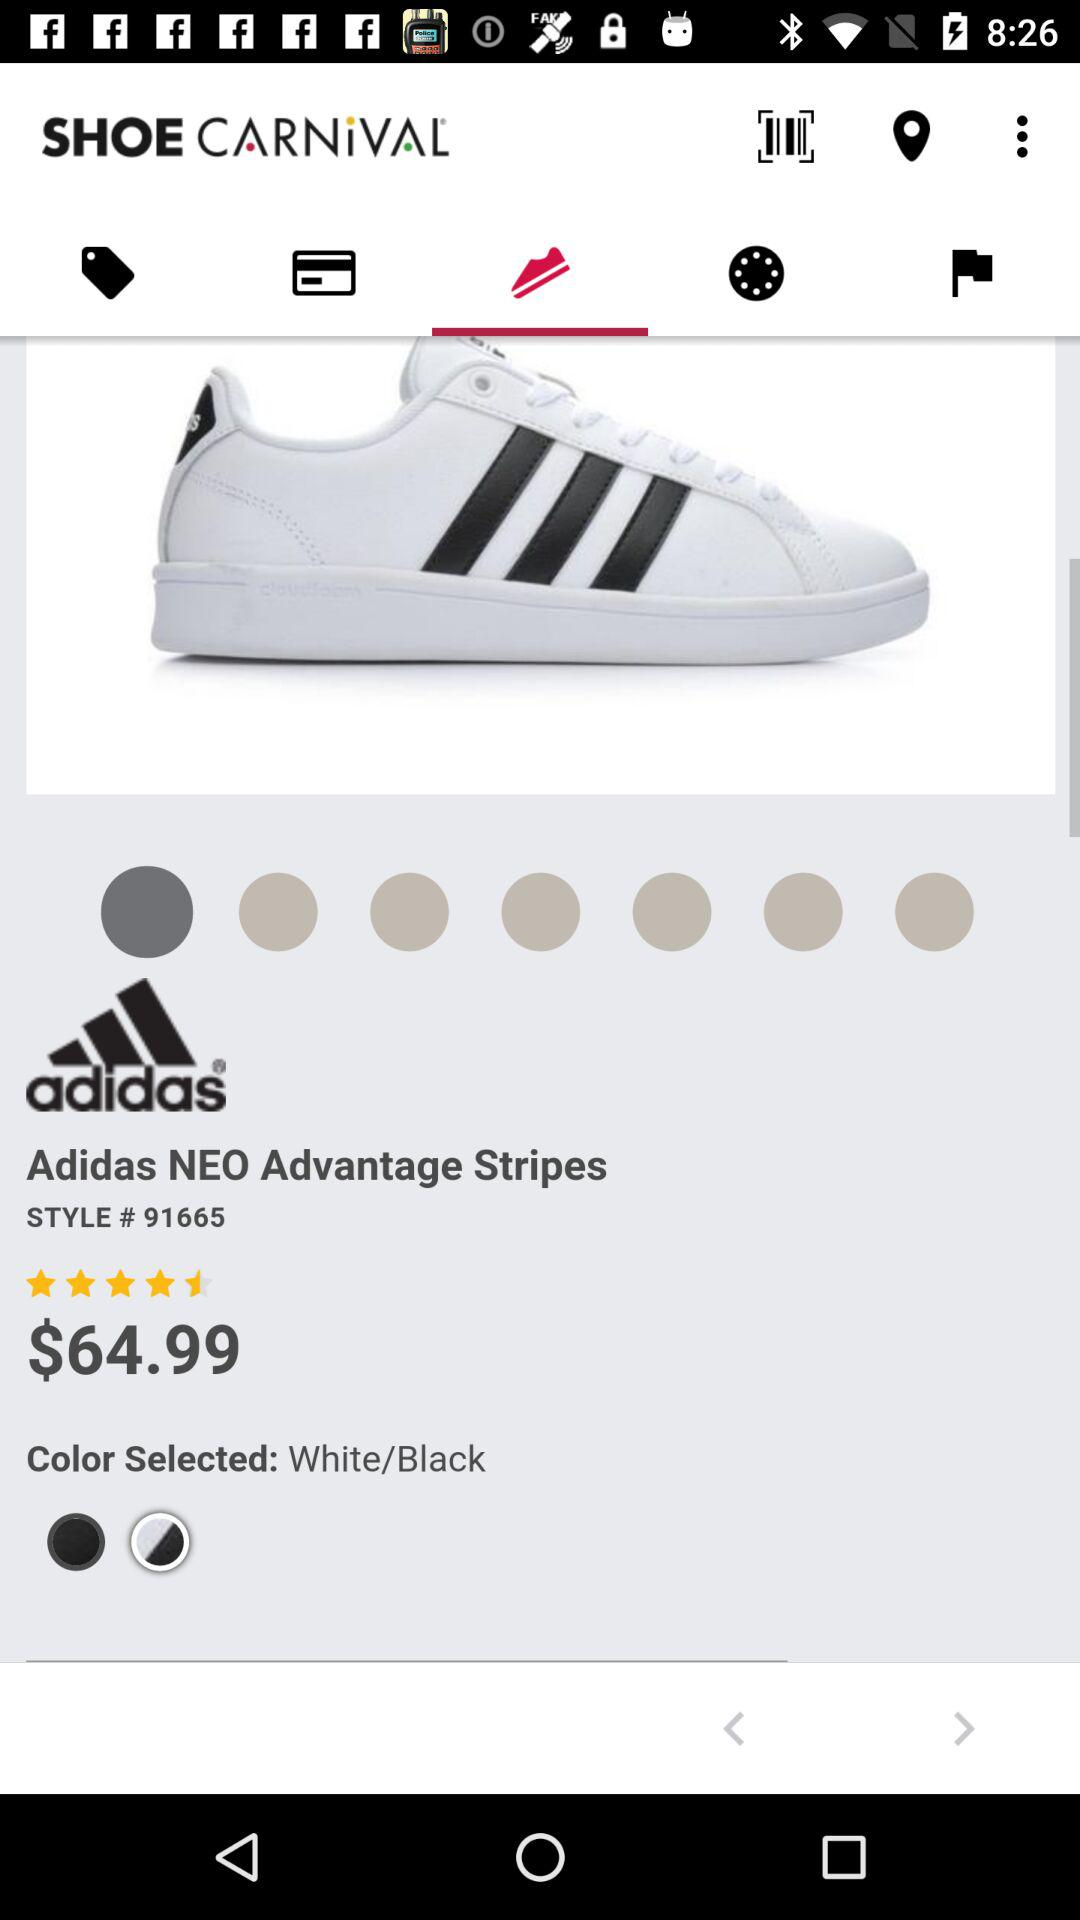What is the cost of the Adidas NEO Advantage stripes? The cost is $64.99. 